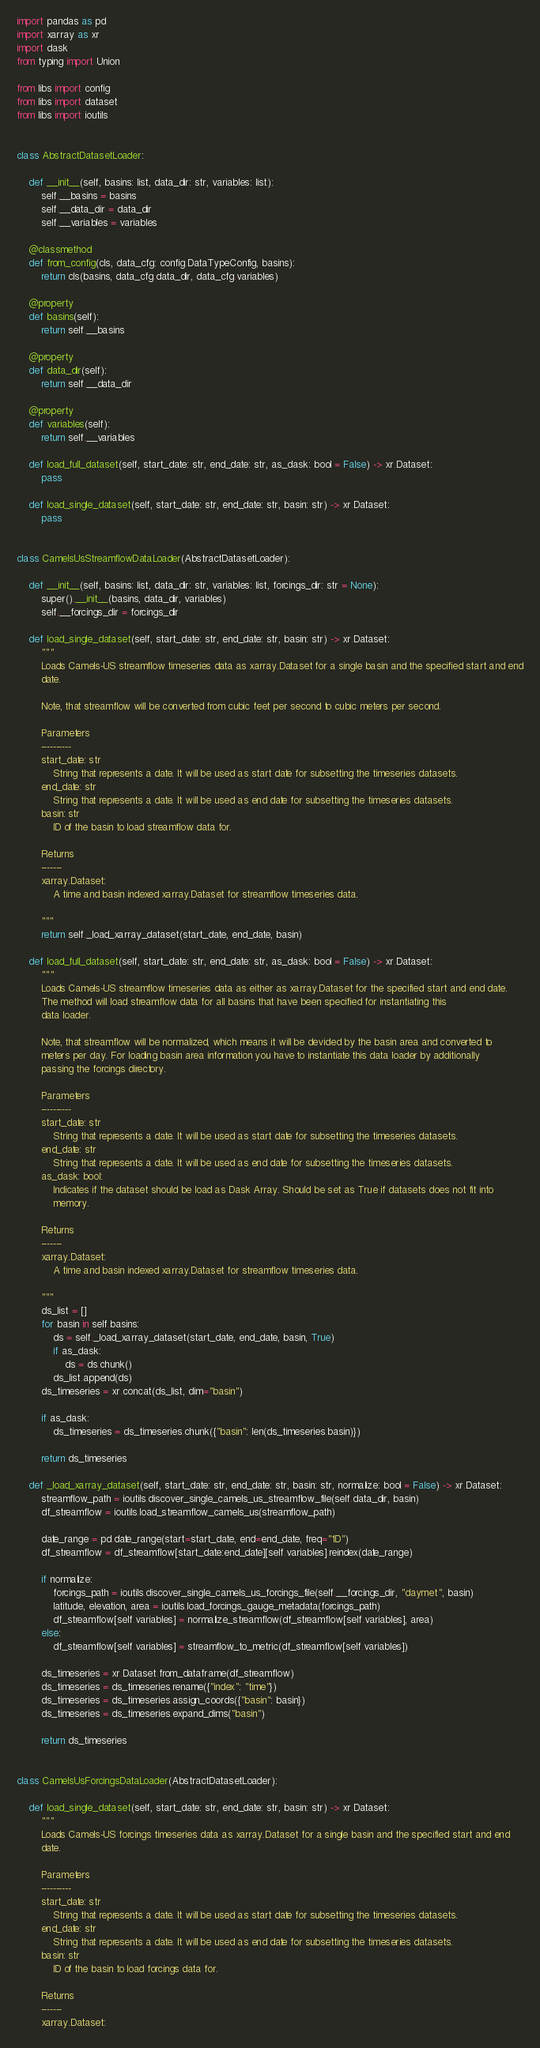<code> <loc_0><loc_0><loc_500><loc_500><_Python_>import pandas as pd
import xarray as xr
import dask
from typing import Union

from libs import config
from libs import dataset
from libs import ioutils


class AbstractDatasetLoader:

    def __init__(self, basins: list, data_dir: str, variables: list):
        self.__basins = basins
        self.__data_dir = data_dir
        self.__variables = variables

    @classmethod
    def from_config(cls, data_cfg: config.DataTypeConfig, basins):
        return cls(basins, data_cfg.data_dir, data_cfg.variables)

    @property
    def basins(self):
        return self.__basins

    @property
    def data_dir(self):
        return self.__data_dir

    @property
    def variables(self):
        return self.__variables

    def load_full_dataset(self, start_date: str, end_date: str, as_dask: bool = False) -> xr.Dataset:
        pass

    def load_single_dataset(self, start_date: str, end_date: str, basin: str) -> xr.Dataset:
        pass


class CamelsUsStreamflowDataLoader(AbstractDatasetLoader):

    def __init__(self, basins: list, data_dir: str, variables: list, forcings_dir: str = None):
        super().__init__(basins, data_dir, variables)
        self.__forcings_dir = forcings_dir

    def load_single_dataset(self, start_date: str, end_date: str, basin: str) -> xr.Dataset:
        """
        Loads Camels-US streamflow timeseries data as xarray.Dataset for a single basin and the specified start and end
        date.

        Note, that streamflow will be converted from cubic feet per second to cubic meters per second.

        Parameters
        ----------
        start_date: str
            String that represents a date. It will be used as start date for subsetting the timeseries datasets.
        end_date: str
            String that represents a date. It will be used as end date for subsetting the timeseries datasets.
        basin: str
            ID of the basin to load streamflow data for.

        Returns
        -------
        xarray.Dataset:
            A time and basin indexed xarray.Dataset for streamflow timeseries data.

        """
        return self._load_xarray_dataset(start_date, end_date, basin)

    def load_full_dataset(self, start_date: str, end_date: str, as_dask: bool = False) -> xr.Dataset:
        """
        Loads Camels-US streamflow timeseries data as either as xarray.Dataset for the specified start and end date.
        The method will load streamflow data for all basins that have been specified for instantiating this
        data loader.

        Note, that streamflow will be normalized, which means it will be devided by the basin area and converted to
        meters per day. For loading basin area information you have to instantiate this data loader by additionally
        passing the forcings directory.

        Parameters
        ----------
        start_date: str
            String that represents a date. It will be used as start date for subsetting the timeseries datasets.
        end_date: str
            String that represents a date. It will be used as end date for subsetting the timeseries datasets.
        as_dask: bool:
            Indicates if the dataset should be load as Dask Array. Should be set as True if datasets does not fit into
            memory.

        Returns
        -------
        xarray.Dataset:
            A time and basin indexed xarray.Dataset for streamflow timeseries data.

        """
        ds_list = []
        for basin in self.basins:
            ds = self._load_xarray_dataset(start_date, end_date, basin, True)
            if as_dask:
                ds = ds.chunk()
            ds_list.append(ds)
        ds_timeseries = xr.concat(ds_list, dim="basin")

        if as_dask:
            ds_timeseries = ds_timeseries.chunk({"basin": len(ds_timeseries.basin)})

        return ds_timeseries

    def _load_xarray_dataset(self, start_date: str, end_date: str, basin: str, normalize: bool = False) -> xr.Dataset:
        streamflow_path = ioutils.discover_single_camels_us_streamflow_file(self.data_dir, basin)
        df_streamflow = ioutils.load_streamflow_camels_us(streamflow_path)

        date_range = pd.date_range(start=start_date, end=end_date, freq="1D")
        df_streamflow = df_streamflow[start_date:end_date][self.variables].reindex(date_range)

        if normalize:
            forcings_path = ioutils.discover_single_camels_us_forcings_file(self.__forcings_dir, "daymet", basin)
            latitude, elevation, area = ioutils.load_forcings_gauge_metadata(forcings_path)
            df_streamflow[self.variables] = normalize_streamflow(df_streamflow[self.variables], area)
        else:
            df_streamflow[self.variables] = streamflow_to_metric(df_streamflow[self.variables])

        ds_timeseries = xr.Dataset.from_dataframe(df_streamflow)
        ds_timeseries = ds_timeseries.rename({"index": "time"})
        ds_timeseries = ds_timeseries.assign_coords({"basin": basin})
        ds_timeseries = ds_timeseries.expand_dims("basin")

        return ds_timeseries


class CamelsUsForcingsDataLoader(AbstractDatasetLoader):

    def load_single_dataset(self, start_date: str, end_date: str, basin: str) -> xr.Dataset:
        """
        Loads Camels-US forcings timeseries data as xarray.Dataset for a single basin and the specified start and end
        date.

        Parameters
        ----------
        start_date: str
            String that represents a date. It will be used as start date for subsetting the timeseries datasets.
        end_date: str
            String that represents a date. It will be used as end date for subsetting the timeseries datasets.
        basin: str
            ID of the basin to load forcings data for.

        Returns
        -------
        xarray.Dataset:</code> 